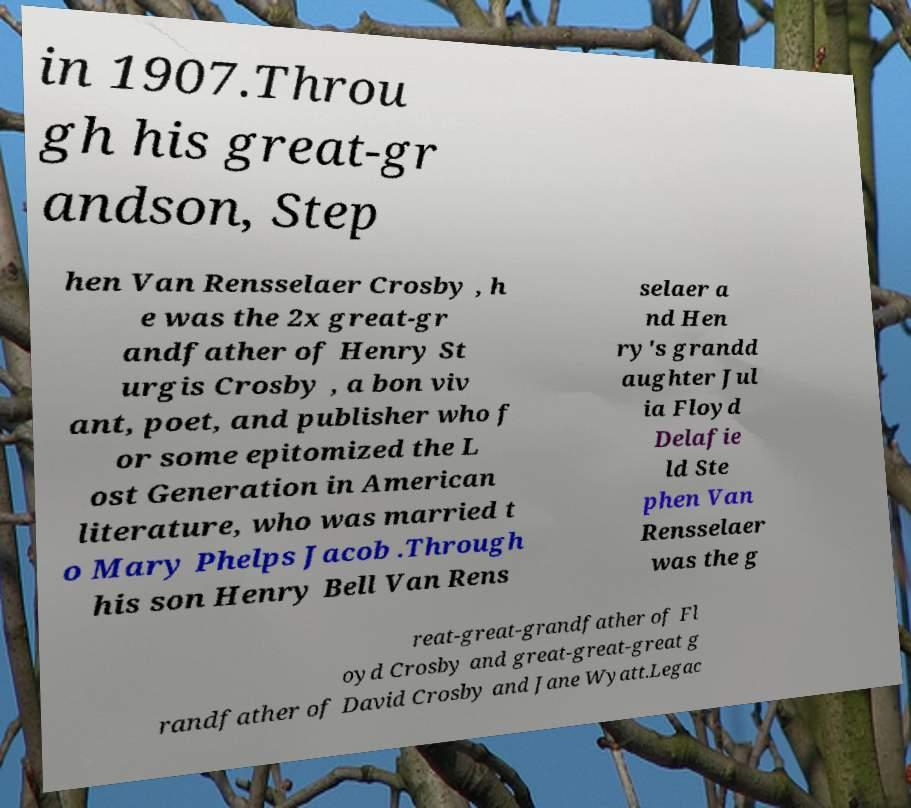I need the written content from this picture converted into text. Can you do that? in 1907.Throu gh his great-gr andson, Step hen Van Rensselaer Crosby , h e was the 2x great-gr andfather of Henry St urgis Crosby , a bon viv ant, poet, and publisher who f or some epitomized the L ost Generation in American literature, who was married t o Mary Phelps Jacob .Through his son Henry Bell Van Rens selaer a nd Hen ry's grandd aughter Jul ia Floyd Delafie ld Ste phen Van Rensselaer was the g reat-great-grandfather of Fl oyd Crosby and great-great-great g randfather of David Crosby and Jane Wyatt.Legac 